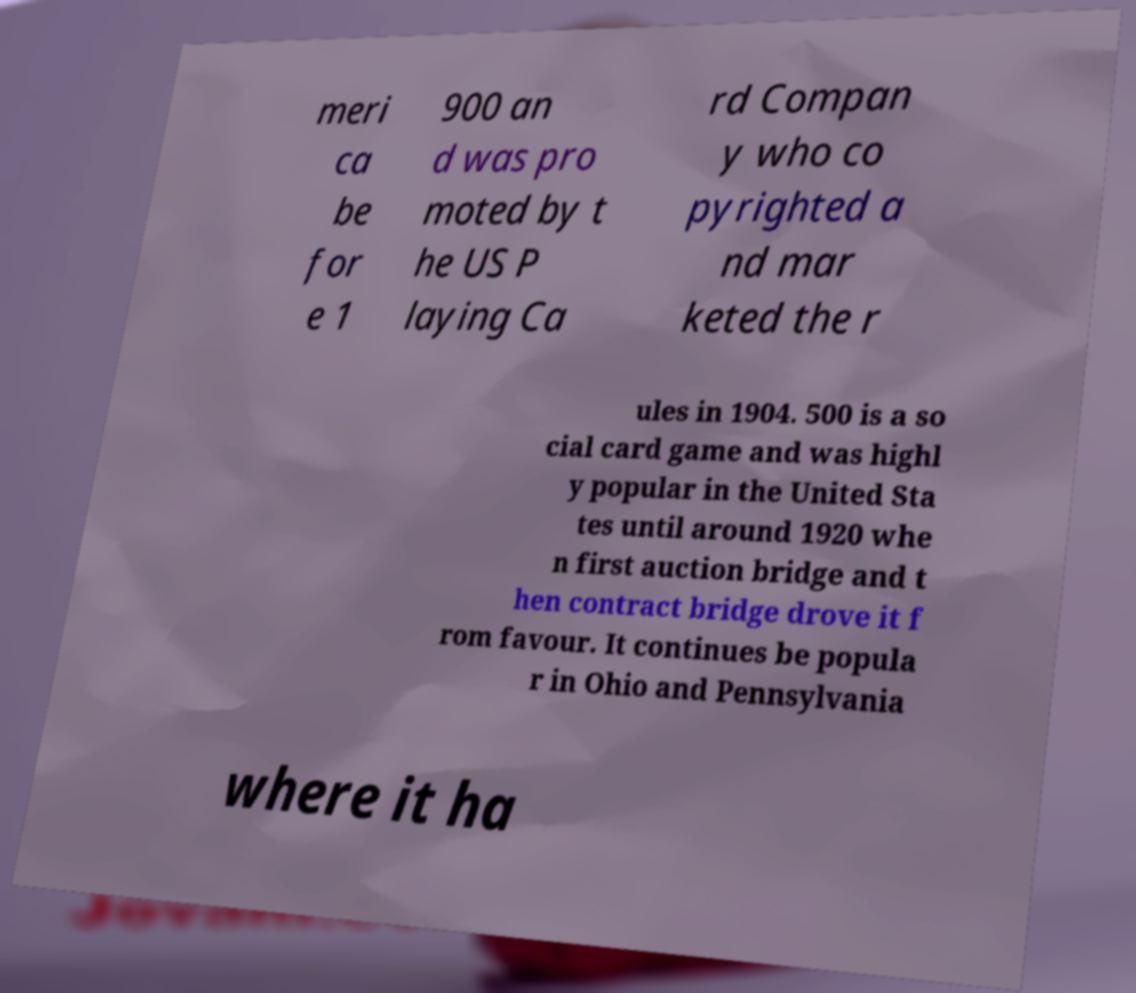What messages or text are displayed in this image? I need them in a readable, typed format. meri ca be for e 1 900 an d was pro moted by t he US P laying Ca rd Compan y who co pyrighted a nd mar keted the r ules in 1904. 500 is a so cial card game and was highl y popular in the United Sta tes until around 1920 whe n first auction bridge and t hen contract bridge drove it f rom favour. It continues be popula r in Ohio and Pennsylvania where it ha 